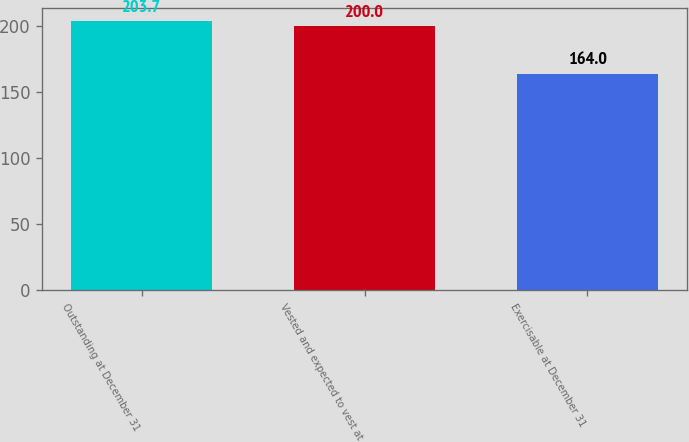Convert chart to OTSL. <chart><loc_0><loc_0><loc_500><loc_500><bar_chart><fcel>Outstanding at December 31<fcel>Vested and expected to vest at<fcel>Exercisable at December 31<nl><fcel>203.7<fcel>200<fcel>164<nl></chart> 